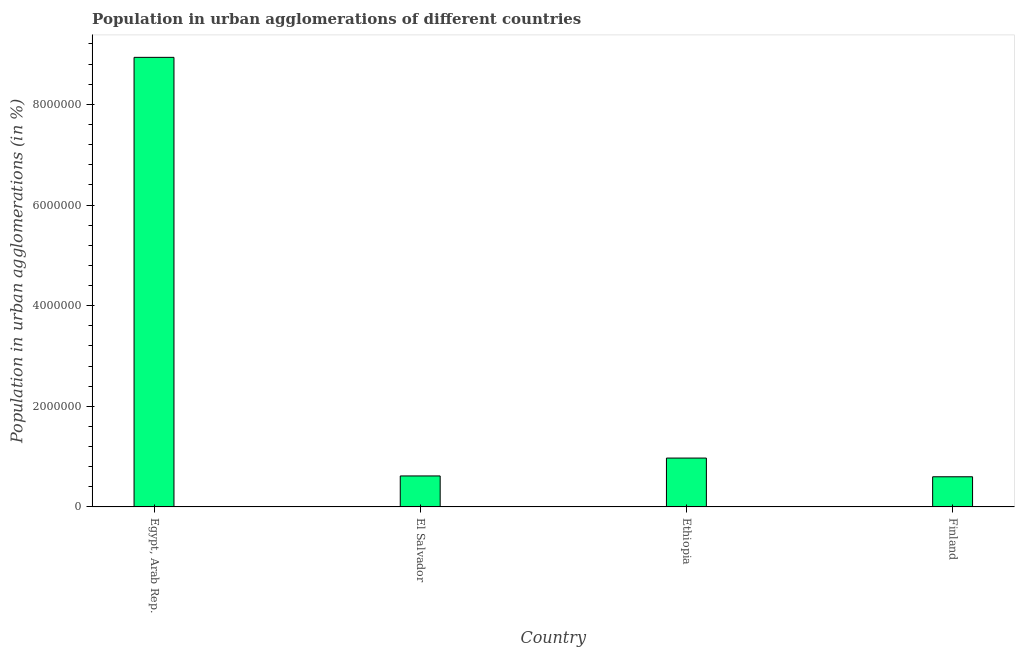Does the graph contain any zero values?
Provide a succinct answer. No. Does the graph contain grids?
Ensure brevity in your answer.  No. What is the title of the graph?
Give a very brief answer. Population in urban agglomerations of different countries. What is the label or title of the Y-axis?
Ensure brevity in your answer.  Population in urban agglomerations (in %). What is the population in urban agglomerations in Ethiopia?
Provide a succinct answer. 9.71e+05. Across all countries, what is the maximum population in urban agglomerations?
Provide a succinct answer. 8.93e+06. Across all countries, what is the minimum population in urban agglomerations?
Provide a succinct answer. 5.99e+05. In which country was the population in urban agglomerations maximum?
Your answer should be compact. Egypt, Arab Rep. In which country was the population in urban agglomerations minimum?
Your answer should be very brief. Finland. What is the sum of the population in urban agglomerations?
Your response must be concise. 1.11e+07. What is the difference between the population in urban agglomerations in Ethiopia and Finland?
Offer a terse response. 3.72e+05. What is the average population in urban agglomerations per country?
Provide a succinct answer. 2.78e+06. What is the median population in urban agglomerations?
Provide a short and direct response. 7.93e+05. In how many countries, is the population in urban agglomerations greater than 8000000 %?
Keep it short and to the point. 1. What is the ratio of the population in urban agglomerations in Egypt, Arab Rep. to that in Ethiopia?
Your response must be concise. 9.2. Is the population in urban agglomerations in Ethiopia less than that in Finland?
Make the answer very short. No. What is the difference between the highest and the second highest population in urban agglomerations?
Your answer should be very brief. 7.96e+06. Is the sum of the population in urban agglomerations in Egypt, Arab Rep. and El Salvador greater than the maximum population in urban agglomerations across all countries?
Provide a succinct answer. Yes. What is the difference between the highest and the lowest population in urban agglomerations?
Make the answer very short. 8.34e+06. In how many countries, is the population in urban agglomerations greater than the average population in urban agglomerations taken over all countries?
Your answer should be compact. 1. How many countries are there in the graph?
Provide a short and direct response. 4. What is the Population in urban agglomerations (in %) of Egypt, Arab Rep.?
Ensure brevity in your answer.  8.93e+06. What is the Population in urban agglomerations (in %) of El Salvador?
Offer a terse response. 6.16e+05. What is the Population in urban agglomerations (in %) of Ethiopia?
Make the answer very short. 9.71e+05. What is the Population in urban agglomerations (in %) of Finland?
Keep it short and to the point. 5.99e+05. What is the difference between the Population in urban agglomerations (in %) in Egypt, Arab Rep. and El Salvador?
Your response must be concise. 8.32e+06. What is the difference between the Population in urban agglomerations (in %) in Egypt, Arab Rep. and Ethiopia?
Offer a terse response. 7.96e+06. What is the difference between the Population in urban agglomerations (in %) in Egypt, Arab Rep. and Finland?
Make the answer very short. 8.34e+06. What is the difference between the Population in urban agglomerations (in %) in El Salvador and Ethiopia?
Offer a very short reply. -3.55e+05. What is the difference between the Population in urban agglomerations (in %) in El Salvador and Finland?
Give a very brief answer. 1.64e+04. What is the difference between the Population in urban agglomerations (in %) in Ethiopia and Finland?
Provide a succinct answer. 3.72e+05. What is the ratio of the Population in urban agglomerations (in %) in Egypt, Arab Rep. to that in El Salvador?
Offer a very short reply. 14.51. What is the ratio of the Population in urban agglomerations (in %) in Egypt, Arab Rep. to that in Ethiopia?
Provide a short and direct response. 9.2. What is the ratio of the Population in urban agglomerations (in %) in Egypt, Arab Rep. to that in Finland?
Offer a very short reply. 14.9. What is the ratio of the Population in urban agglomerations (in %) in El Salvador to that in Ethiopia?
Your response must be concise. 0.63. What is the ratio of the Population in urban agglomerations (in %) in El Salvador to that in Finland?
Provide a short and direct response. 1.03. What is the ratio of the Population in urban agglomerations (in %) in Ethiopia to that in Finland?
Make the answer very short. 1.62. 